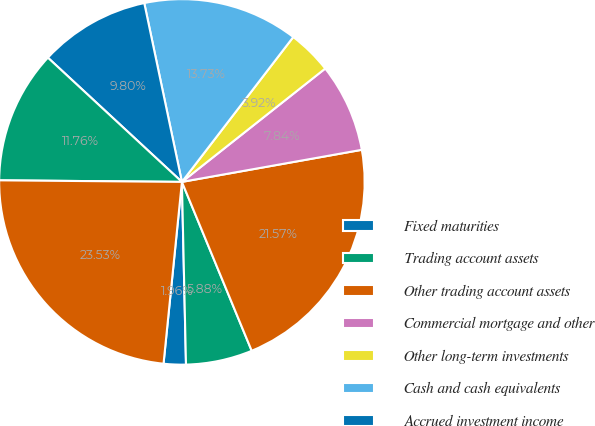Convert chart to OTSL. <chart><loc_0><loc_0><loc_500><loc_500><pie_chart><fcel>Fixed maturities<fcel>Trading account assets<fcel>Other trading account assets<fcel>Commercial mortgage and other<fcel>Other long-term investments<fcel>Cash and cash equivalents<fcel>Accrued investment income<fcel>Other assets<fcel>Total assets of consolidated<nl><fcel>1.96%<fcel>5.88%<fcel>21.57%<fcel>7.84%<fcel>3.92%<fcel>13.73%<fcel>9.8%<fcel>11.76%<fcel>23.53%<nl></chart> 